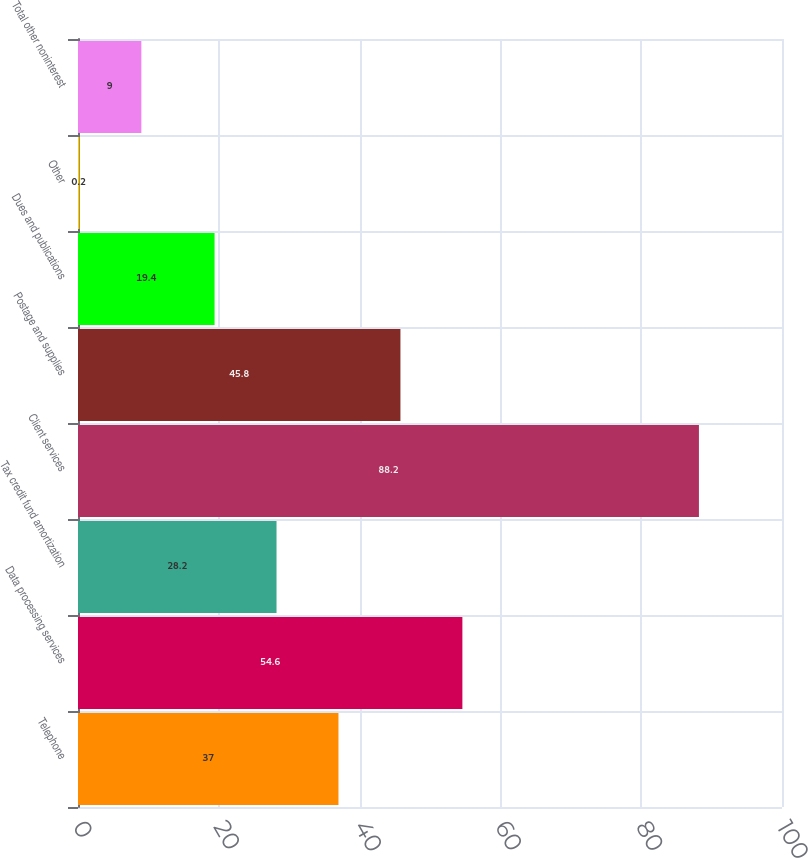<chart> <loc_0><loc_0><loc_500><loc_500><bar_chart><fcel>Telephone<fcel>Data processing services<fcel>Tax credit fund amortization<fcel>Client services<fcel>Postage and supplies<fcel>Dues and publications<fcel>Other<fcel>Total other noninterest<nl><fcel>37<fcel>54.6<fcel>28.2<fcel>88.2<fcel>45.8<fcel>19.4<fcel>0.2<fcel>9<nl></chart> 